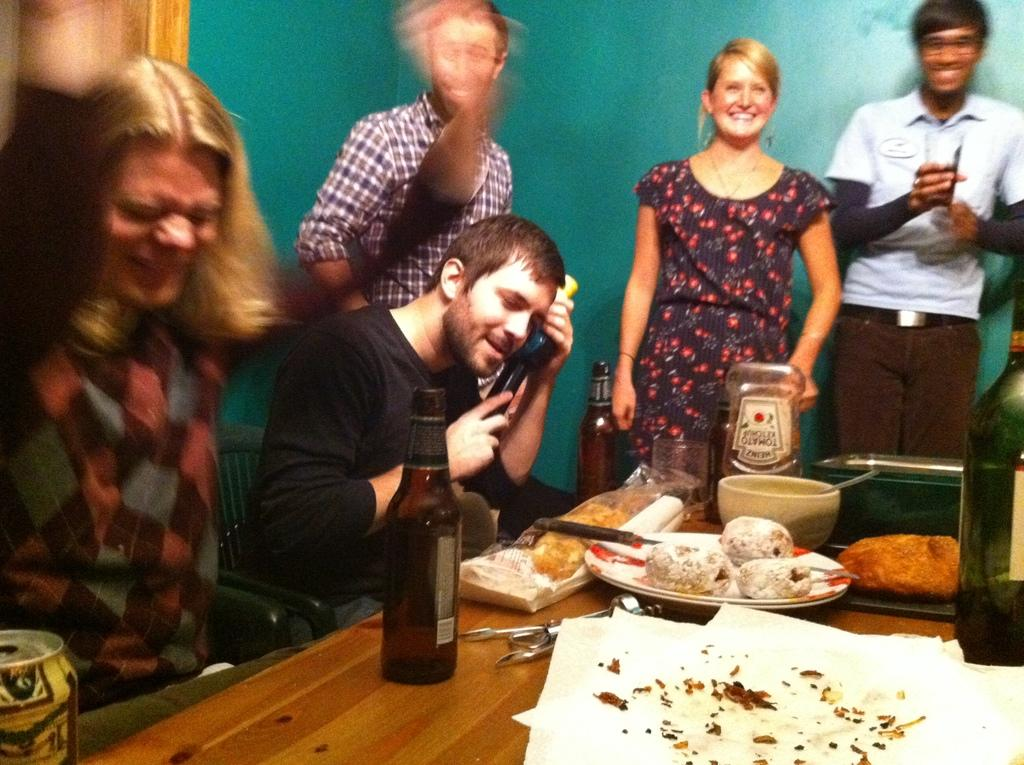How many people are in the image? There is a group of people in the image, but the exact number is not specified. What are some people doing in the image? Some people are seated in chairs, while others are standing. What can be seen on the table in the image? There is food, plates, and bottles on the table in the image. What type of show is being performed on the dock in the image? There is no dock or show present in the image; it features a group of people with some seated and standing, along with a table containing food, plates, and bottles. 